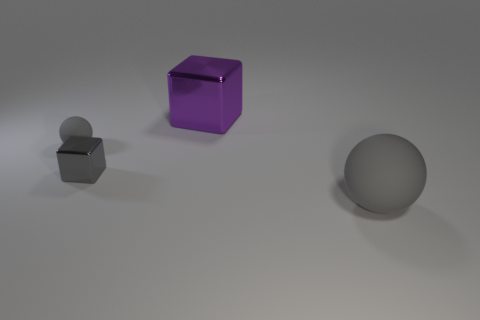Add 3 cyan cubes. How many objects exist? 7 Add 4 gray things. How many gray things are left? 7 Add 1 blue matte things. How many blue matte things exist? 1 Subtract 0 yellow cubes. How many objects are left? 4 Subtract all large red rubber spheres. Subtract all gray matte objects. How many objects are left? 2 